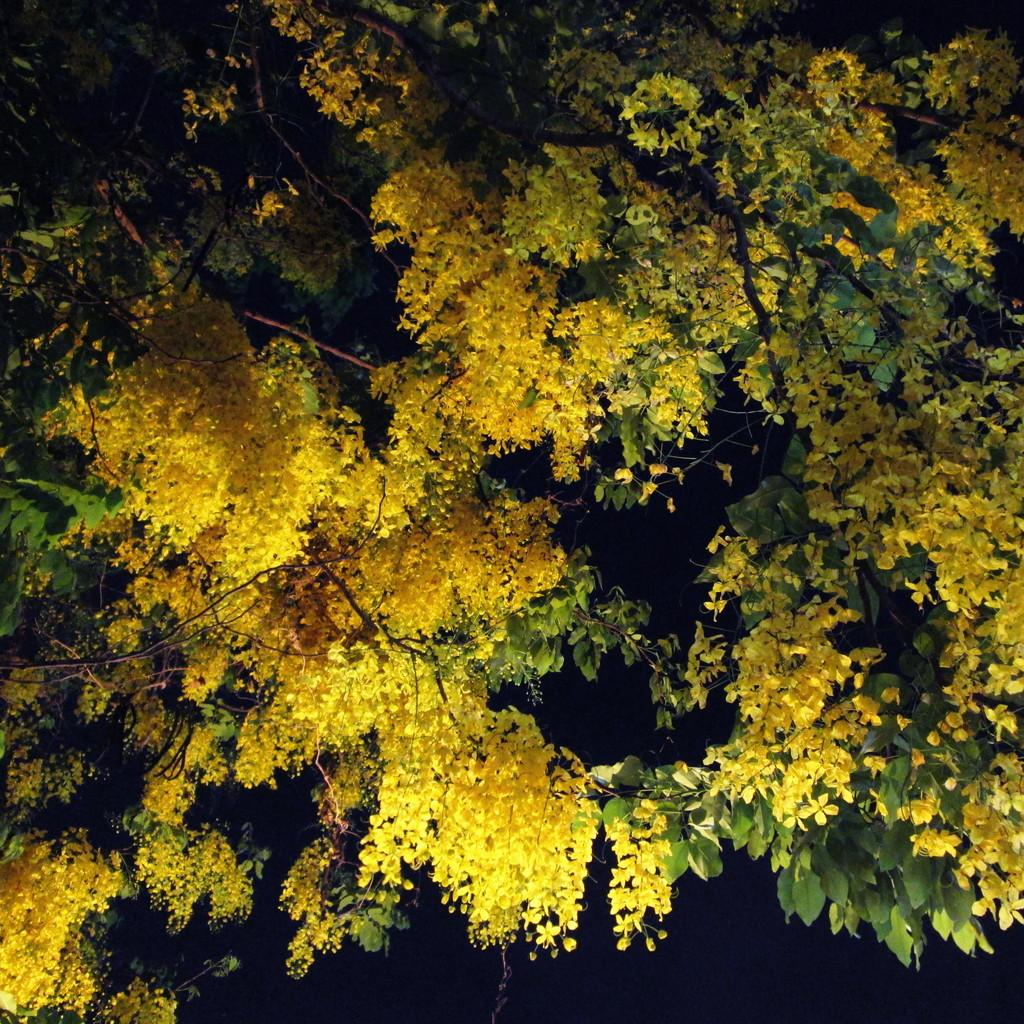What type of vegetation can be seen in the image? There are trees and flowers in the image. Can you describe the lighting in the image? The image is a little dark. What type of ground can be seen in the image? There is no specific ground mentioned or visible in the image; it only shows trees and flowers. 